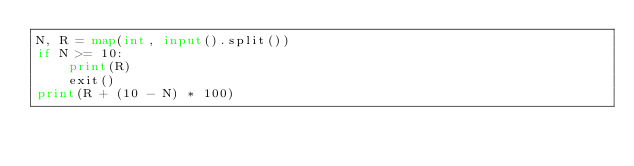Convert code to text. <code><loc_0><loc_0><loc_500><loc_500><_Python_>N, R = map(int, input().split())
if N >= 10:
    print(R)
    exit()
print(R + (10 - N) * 100)
</code> 